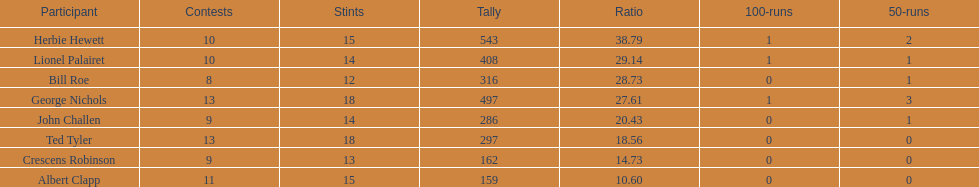How many more runs does john have than albert? 127. Parse the full table. {'header': ['Participant', 'Contests', 'Stints', 'Tally', 'Ratio', '100-runs', '50-runs'], 'rows': [['Herbie Hewett', '10', '15', '543', '38.79', '1', '2'], ['Lionel Palairet', '10', '14', '408', '29.14', '1', '1'], ['Bill Roe', '8', '12', '316', '28.73', '0', '1'], ['George Nichols', '13', '18', '497', '27.61', '1', '3'], ['John Challen', '9', '14', '286', '20.43', '0', '1'], ['Ted Tyler', '13', '18', '297', '18.56', '0', '0'], ['Crescens Robinson', '9', '13', '162', '14.73', '0', '0'], ['Albert Clapp', '11', '15', '159', '10.60', '0', '0']]} 